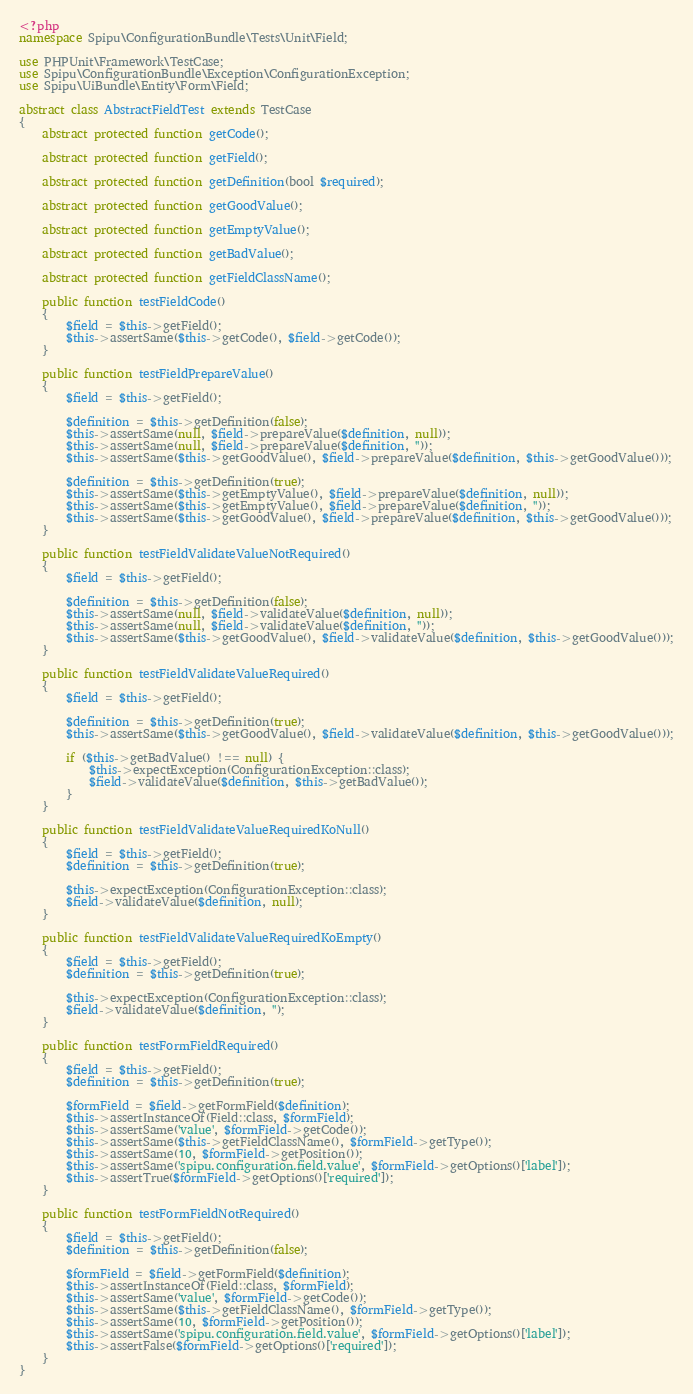Convert code to text. <code><loc_0><loc_0><loc_500><loc_500><_PHP_><?php
namespace Spipu\ConfigurationBundle\Tests\Unit\Field;

use PHPUnit\Framework\TestCase;
use Spipu\ConfigurationBundle\Exception\ConfigurationException;
use Spipu\UiBundle\Entity\Form\Field;

abstract class AbstractFieldTest extends TestCase
{
    abstract protected function getCode();

    abstract protected function getField();

    abstract protected function getDefinition(bool $required);

    abstract protected function getGoodValue();

    abstract protected function getEmptyValue();

    abstract protected function getBadValue();

    abstract protected function getFieldClassName();

    public function testFieldCode()
    {
        $field = $this->getField();
        $this->assertSame($this->getCode(), $field->getCode());
    }

    public function testFieldPrepareValue()
    {
        $field = $this->getField();

        $definition = $this->getDefinition(false);
        $this->assertSame(null, $field->prepareValue($definition, null));
        $this->assertSame(null, $field->prepareValue($definition, ''));
        $this->assertSame($this->getGoodValue(), $field->prepareValue($definition, $this->getGoodValue()));

        $definition = $this->getDefinition(true);
        $this->assertSame($this->getEmptyValue(), $field->prepareValue($definition, null));
        $this->assertSame($this->getEmptyValue(), $field->prepareValue($definition, ''));
        $this->assertSame($this->getGoodValue(), $field->prepareValue($definition, $this->getGoodValue()));
    }

    public function testFieldValidateValueNotRequired()
    {
        $field = $this->getField();

        $definition = $this->getDefinition(false);
        $this->assertSame(null, $field->validateValue($definition, null));
        $this->assertSame(null, $field->validateValue($definition, ''));
        $this->assertSame($this->getGoodValue(), $field->validateValue($definition, $this->getGoodValue()));
    }

    public function testFieldValidateValueRequired()
    {
        $field = $this->getField();

        $definition = $this->getDefinition(true);
        $this->assertSame($this->getGoodValue(), $field->validateValue($definition, $this->getGoodValue()));

        if ($this->getBadValue() !== null) {
            $this->expectException(ConfigurationException::class);
            $field->validateValue($definition, $this->getBadValue());
        }
    }

    public function testFieldValidateValueRequiredKoNull()
    {
        $field = $this->getField();
        $definition = $this->getDefinition(true);

        $this->expectException(ConfigurationException::class);
        $field->validateValue($definition, null);
    }

    public function testFieldValidateValueRequiredKoEmpty()
    {
        $field = $this->getField();
        $definition = $this->getDefinition(true);

        $this->expectException(ConfigurationException::class);
        $field->validateValue($definition, '');
    }

    public function testFormFieldRequired()
    {
        $field = $this->getField();
        $definition = $this->getDefinition(true);

        $formField = $field->getFormField($definition);
        $this->assertInstanceOf(Field::class, $formField);
        $this->assertSame('value', $formField->getCode());
        $this->assertSame($this->getFieldClassName(), $formField->getType());
        $this->assertSame(10, $formField->getPosition());
        $this->assertSame('spipu.configuration.field.value', $formField->getOptions()['label']);
        $this->assertTrue($formField->getOptions()['required']);
    }

    public function testFormFieldNotRequired()
    {
        $field = $this->getField();
        $definition = $this->getDefinition(false);

        $formField = $field->getFormField($definition);
        $this->assertInstanceOf(Field::class, $formField);
        $this->assertSame('value', $formField->getCode());
        $this->assertSame($this->getFieldClassName(), $formField->getType());
        $this->assertSame(10, $formField->getPosition());
        $this->assertSame('spipu.configuration.field.value', $formField->getOptions()['label']);
        $this->assertFalse($formField->getOptions()['required']);
    }
}
</code> 